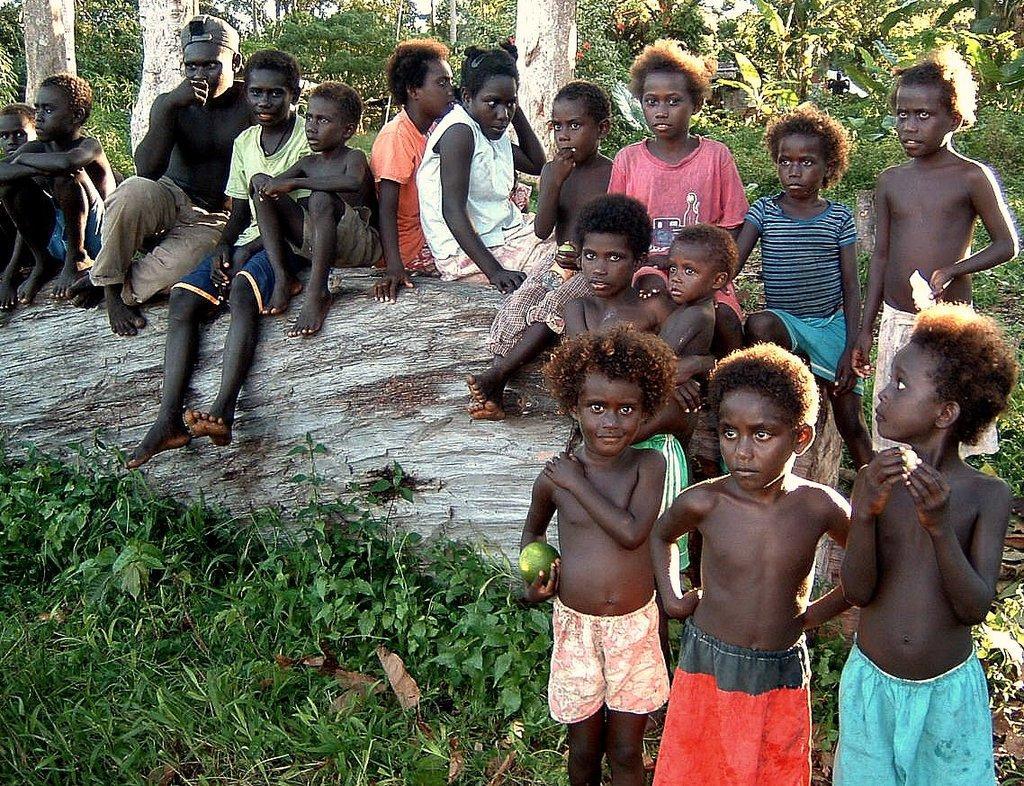Can you describe this image briefly? In this picture we can see many kids sitting and standing on the ground surrounded with trees and grass. 